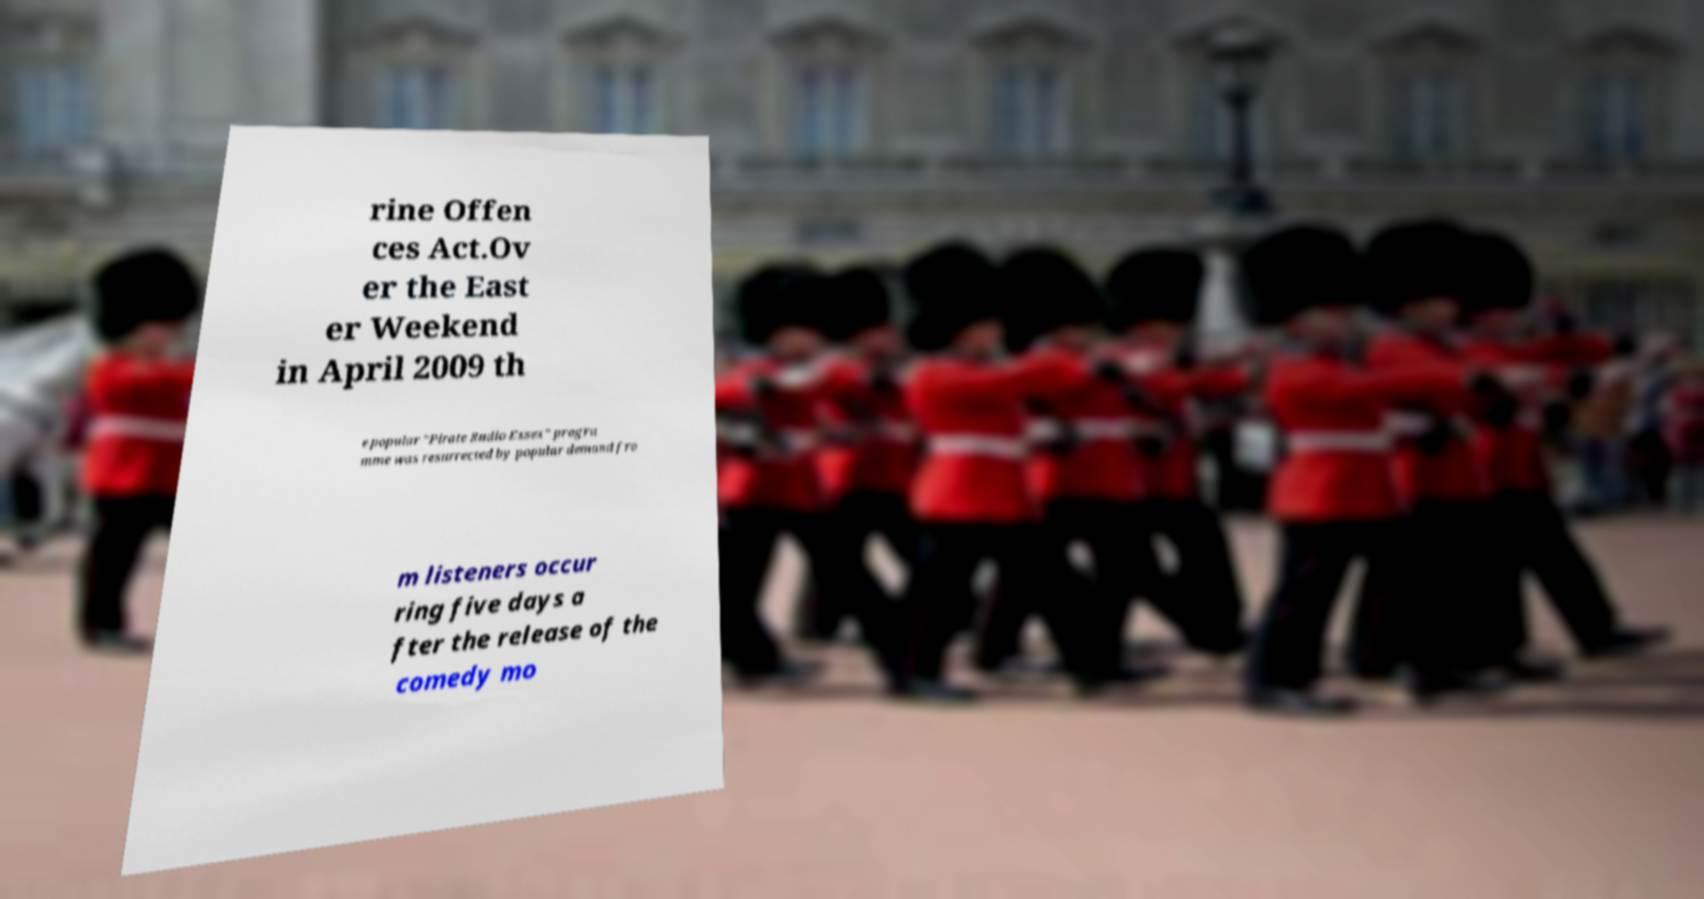Could you assist in decoding the text presented in this image and type it out clearly? rine Offen ces Act.Ov er the East er Weekend in April 2009 th e popular "Pirate Radio Essex" progra mme was resurrected by popular demand fro m listeners occur ring five days a fter the release of the comedy mo 